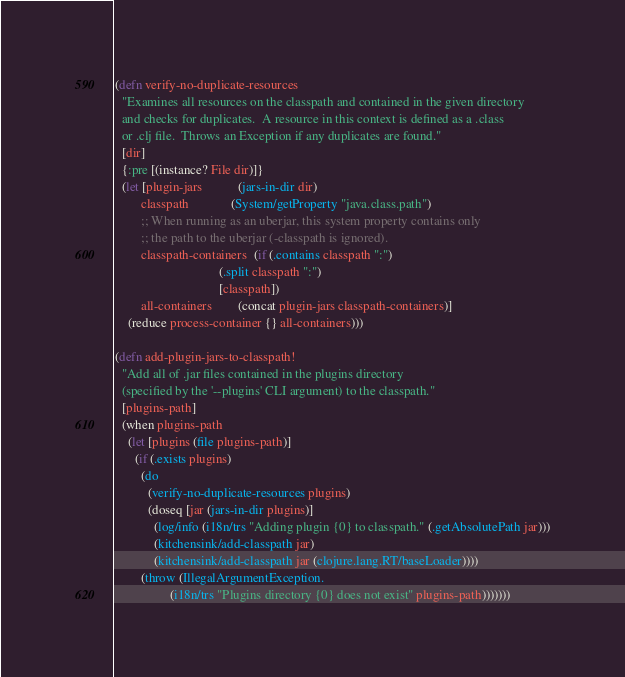<code> <loc_0><loc_0><loc_500><loc_500><_Clojure_>
(defn verify-no-duplicate-resources
  "Examines all resources on the classpath and contained in the given directory
  and checks for duplicates.  A resource in this context is defined as a .class
  or .clj file.  Throws an Exception if any duplicates are found."
  [dir]
  {:pre [(instance? File dir)]}
  (let [plugin-jars           (jars-in-dir dir)
        classpath             (System/getProperty "java.class.path")
        ;; When running as an uberjar, this system property contains only
        ;; the path to the uberjar (-classpath is ignored).
        classpath-containers  (if (.contains classpath ":")
                                (.split classpath ":")
                                [classpath])
        all-containers        (concat plugin-jars classpath-containers)]
    (reduce process-container {} all-containers)))

(defn add-plugin-jars-to-classpath!
  "Add all of .jar files contained in the plugins directory
  (specified by the '--plugins' CLI argument) to the classpath."
  [plugins-path]
  (when plugins-path
    (let [plugins (file plugins-path)]
      (if (.exists plugins)
        (do
          (verify-no-duplicate-resources plugins)
          (doseq [jar (jars-in-dir plugins)]
            (log/info (i18n/trs "Adding plugin {0} to classpath." (.getAbsolutePath jar)))
            (kitchensink/add-classpath jar)
            (kitchensink/add-classpath jar (clojure.lang.RT/baseLoader))))
        (throw (IllegalArgumentException.
                 (i18n/trs "Plugins directory {0} does not exist" plugins-path)))))))
</code> 